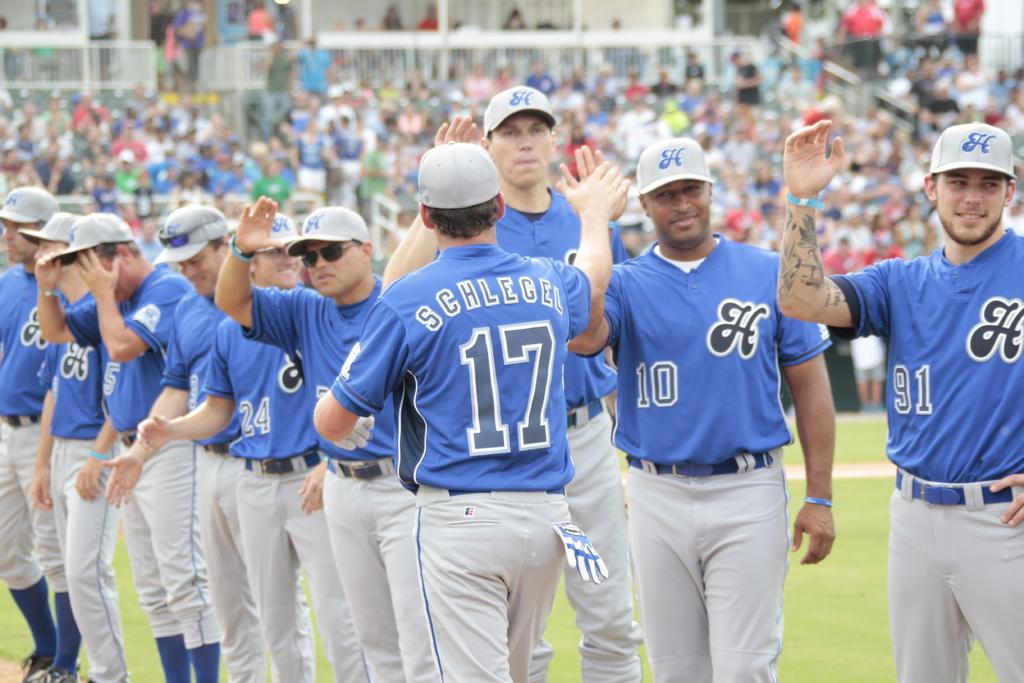<image>
Relay a brief, clear account of the picture shown. A man in a blue uniform with the number 17 on the back is facing the rest of his teammates. 